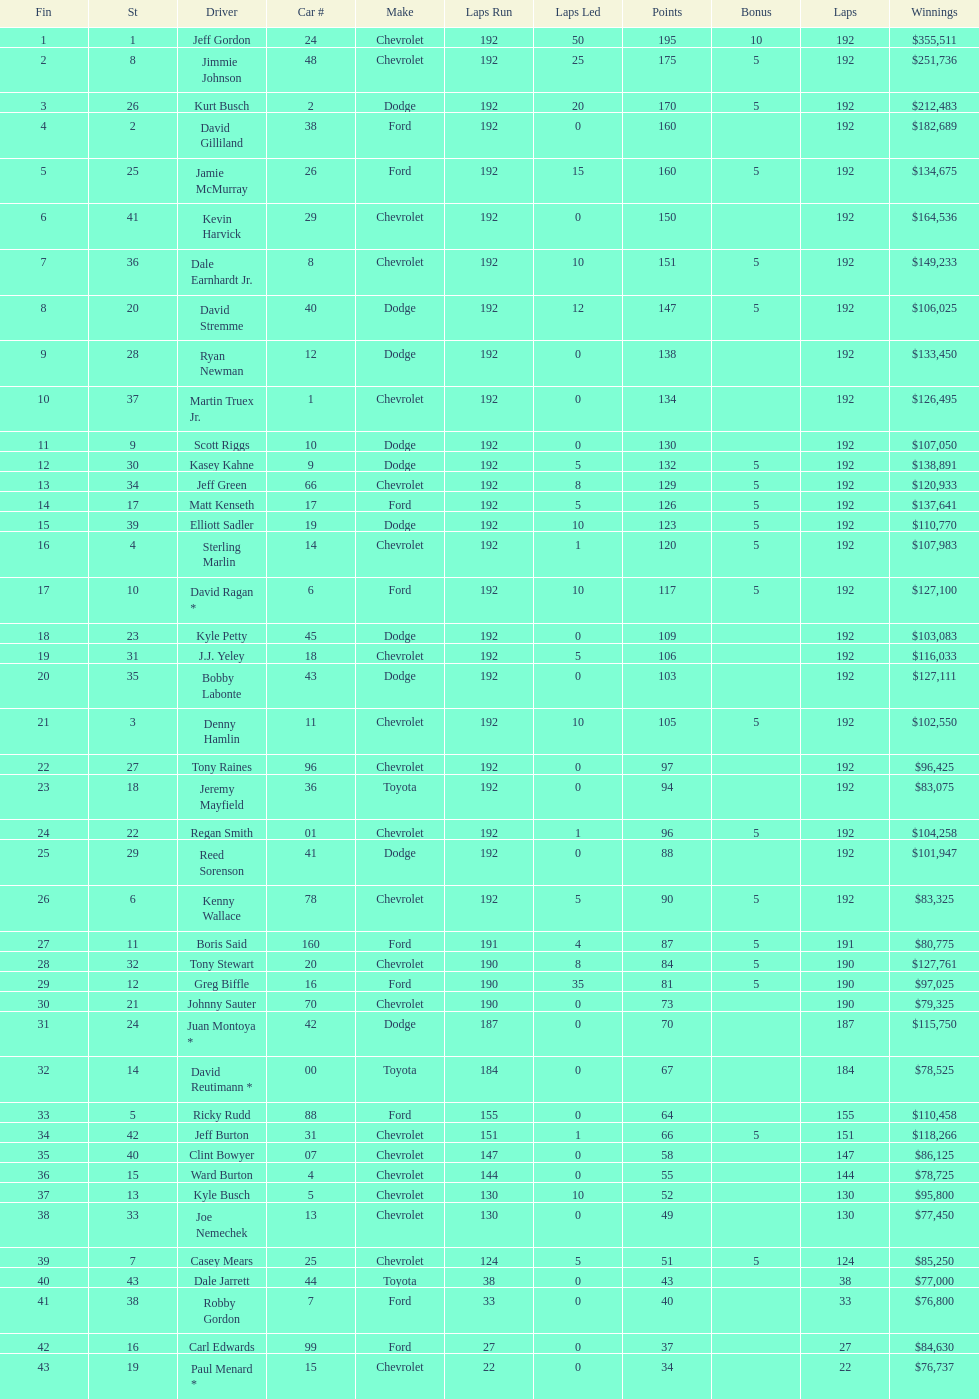What was jimmie johnson's winnings? $251,736. 